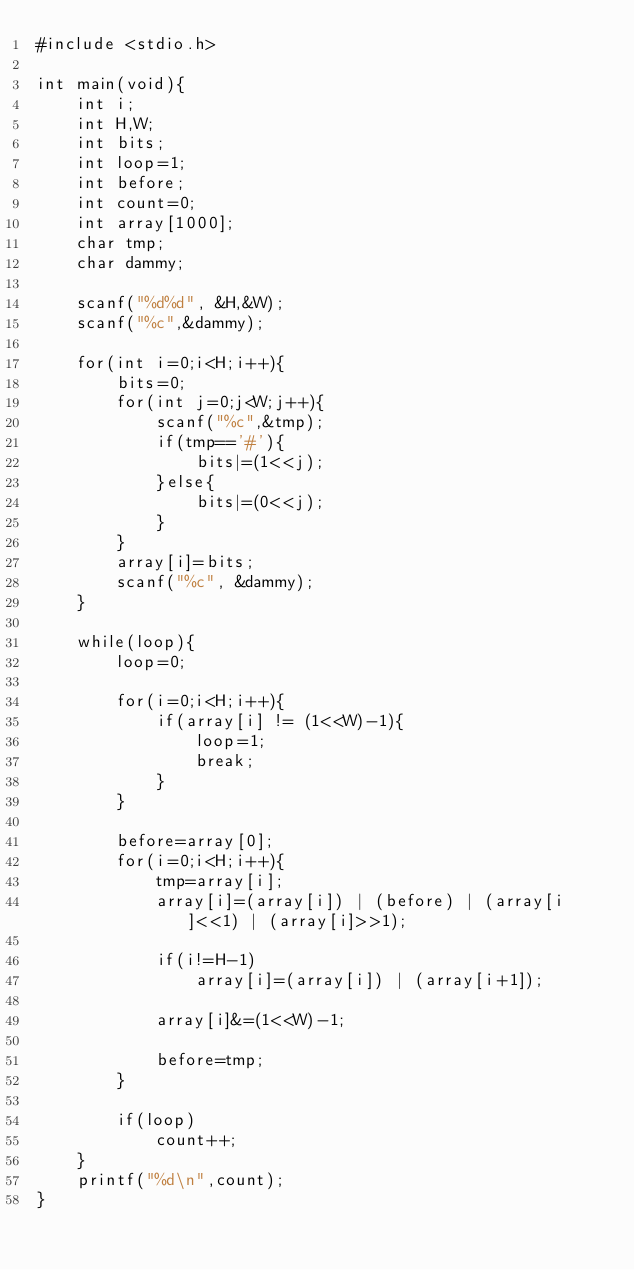<code> <loc_0><loc_0><loc_500><loc_500><_C_>#include <stdio.h>

int main(void){
	int i;
	int H,W;
	int bits;
	int loop=1;
	int before;
	int count=0;
	int array[1000];
	char tmp;
	char dammy;

	scanf("%d%d", &H,&W);
	scanf("%c",&dammy);

	for(int i=0;i<H;i++){
		bits=0;
		for(int j=0;j<W;j++){
			scanf("%c",&tmp);
			if(tmp=='#'){
				bits|=(1<<j);
			}else{
				bits|=(0<<j);
			}
		}
		array[i]=bits;
		scanf("%c", &dammy);
	}
	
	while(loop){
		loop=0;
		
		for(i=0;i<H;i++){
			if(array[i] != (1<<W)-1){
				loop=1;
				break;
			}
		}

		before=array[0];
		for(i=0;i<H;i++){
			tmp=array[i];
			array[i]=(array[i]) | (before) | (array[i]<<1) | (array[i]>>1);

			if(i!=H-1)
				array[i]=(array[i]) | (array[i+1]);

			array[i]&=(1<<W)-1;
			
			before=tmp;
		}

		if(loop)
			count++;
	}
	printf("%d\n",count);
}</code> 